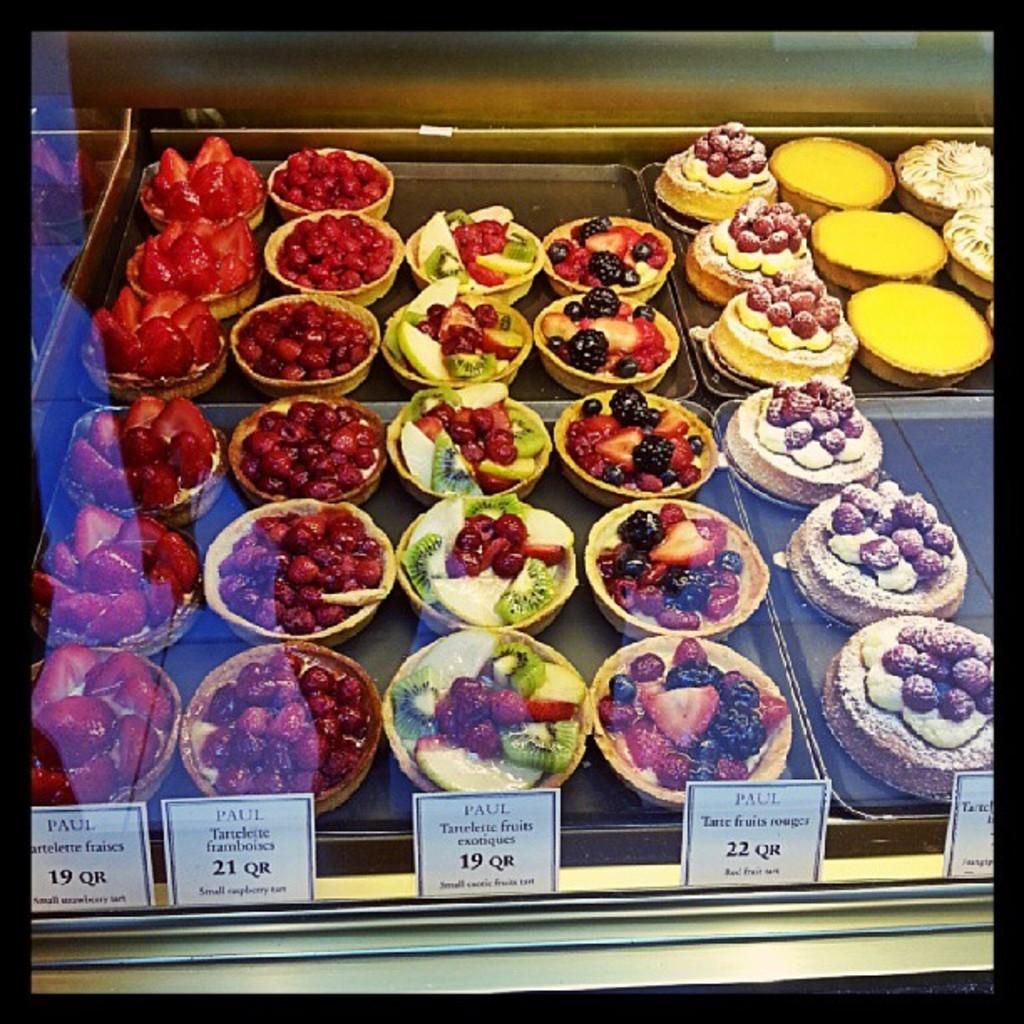What can be seen in the foreground of the image? There are various types of food and different types of cakes in the foreground of the image. Can you describe the food items in the image? Unfortunately, the facts provided do not specify the types of food in the image, but we know that there are various types of food and cakes present. How many tomatoes are on the bone in the image? There are no tomatoes or bones present in the image. What causes the cakes to burst in the image? There is no indication in the image that the cakes are bursting or that any external force is causing them to do so. 